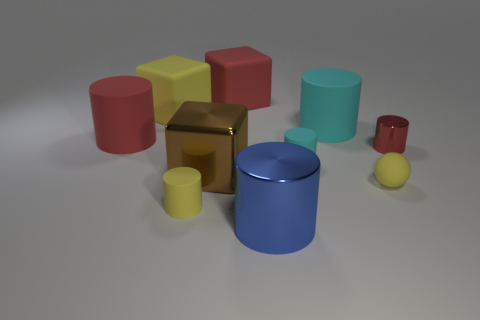Subtract 2 cylinders. How many cylinders are left? 4 Subtract all red cylinders. How many cylinders are left? 4 Subtract all yellow cylinders. How many cylinders are left? 5 Subtract all gray cylinders. Subtract all green balls. How many cylinders are left? 6 Subtract all cylinders. How many objects are left? 4 Add 10 large blue matte cylinders. How many large blue matte cylinders exist? 10 Subtract 1 yellow spheres. How many objects are left? 9 Subtract all yellow shiny cylinders. Subtract all metal blocks. How many objects are left? 9 Add 8 small cyan matte objects. How many small cyan matte objects are left? 9 